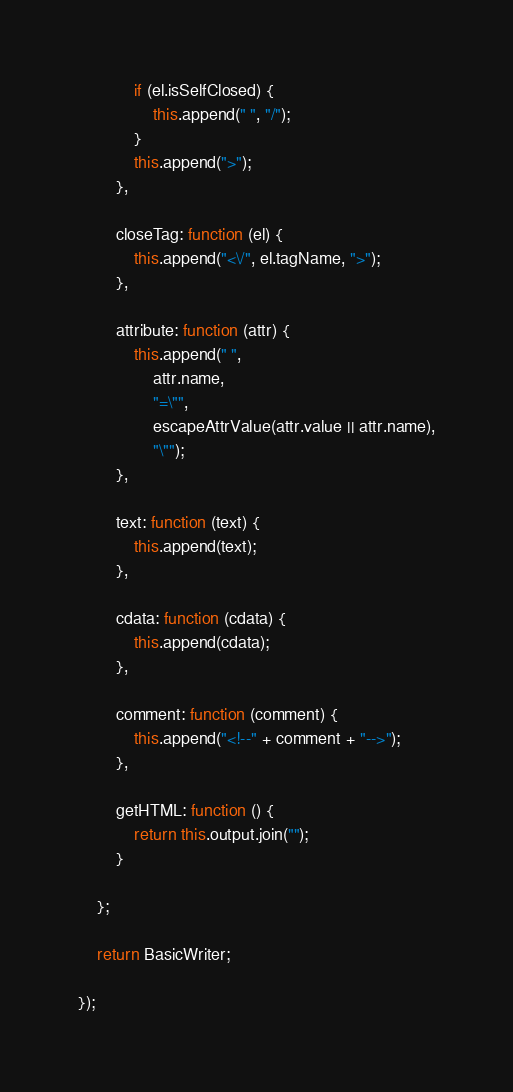Convert code to text. <code><loc_0><loc_0><loc_500><loc_500><_JavaScript_>            if (el.isSelfClosed) {
                this.append(" ", "/");
            }
            this.append(">");
        },

        closeTag: function (el) {
            this.append("<\/", el.tagName, ">");
        },

        attribute: function (attr) {
            this.append(" ",
                attr.name,
                "=\"",
                escapeAttrValue(attr.value || attr.name),
                "\"");
        },

        text: function (text) {
            this.append(text);
        },

        cdata: function (cdata) {
            this.append(cdata);
        },

        comment: function (comment) {
            this.append("<!--" + comment + "-->");
        },

        getHTML: function () {
            return this.output.join("");
        }

    };

    return BasicWriter;

});</code> 